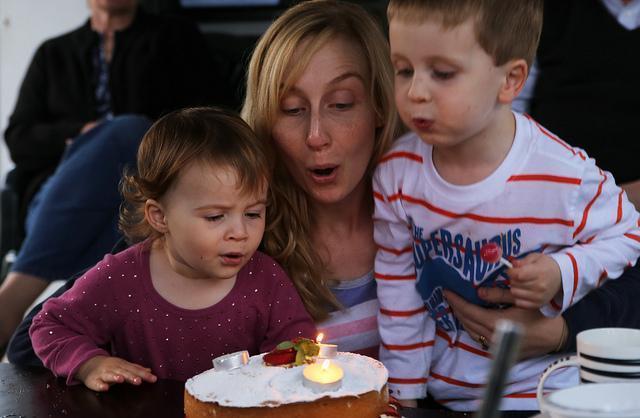How many people are there?
Give a very brief answer. 6. 